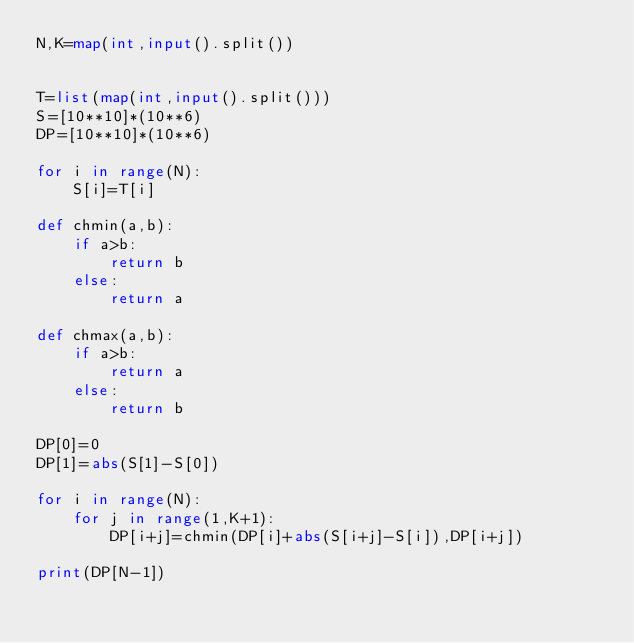Convert code to text. <code><loc_0><loc_0><loc_500><loc_500><_Python_>N,K=map(int,input().split())


T=list(map(int,input().split()))
S=[10**10]*(10**6)
DP=[10**10]*(10**6)

for i in range(N):
    S[i]=T[i]    

def chmin(a,b):
    if a>b:
        return b
    else:
        return a

def chmax(a,b):
    if a>b:
        return a
    else:
        return b

DP[0]=0
DP[1]=abs(S[1]-S[0])

for i in range(N):
    for j in range(1,K+1):
        DP[i+j]=chmin(DP[i]+abs(S[i+j]-S[i]),DP[i+j])
    
print(DP[N-1])
</code> 